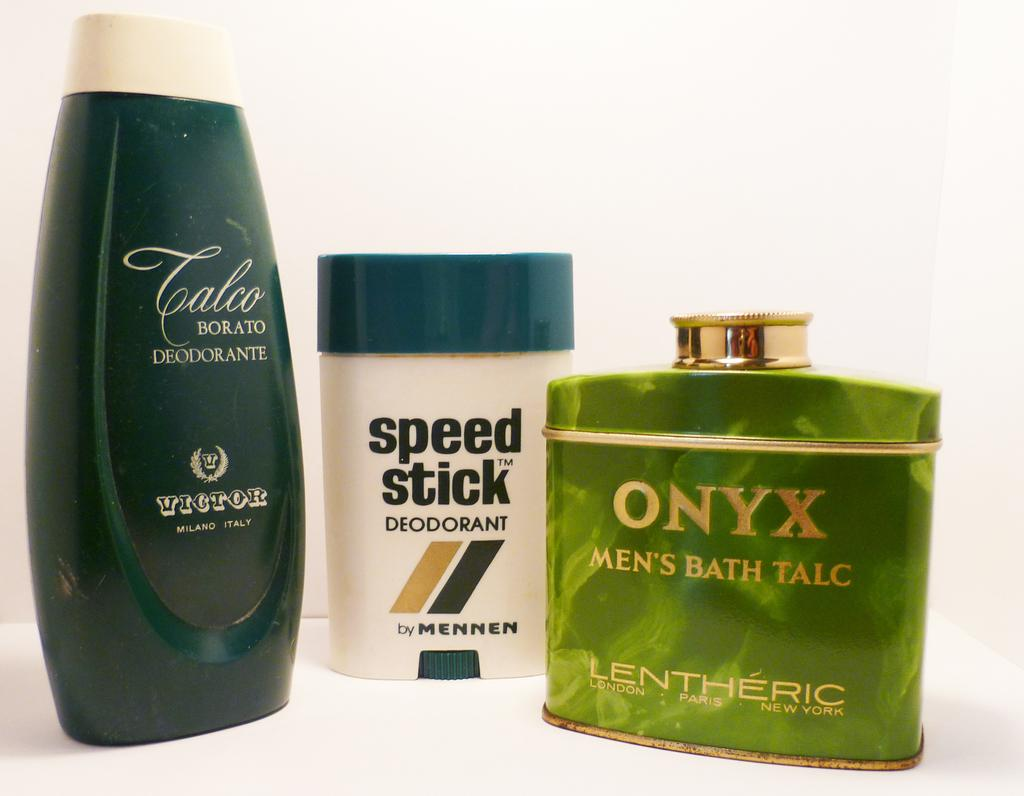<image>
Write a terse but informative summary of the picture. Green bottle of Onyx next to a white Speed Stick deoderant. 